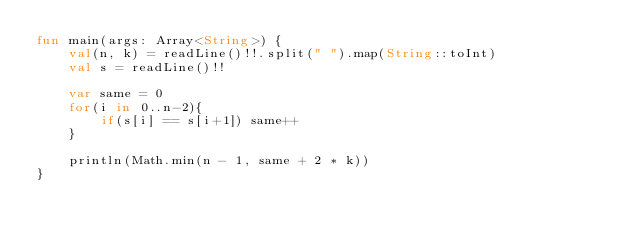Convert code to text. <code><loc_0><loc_0><loc_500><loc_500><_Kotlin_>fun main(args: Array<String>) {
    val(n, k) = readLine()!!.split(" ").map(String::toInt)
    val s = readLine()!!

    var same = 0
    for(i in 0..n-2){
        if(s[i] == s[i+1]) same++
    }

    println(Math.min(n - 1, same + 2 * k))
}
</code> 